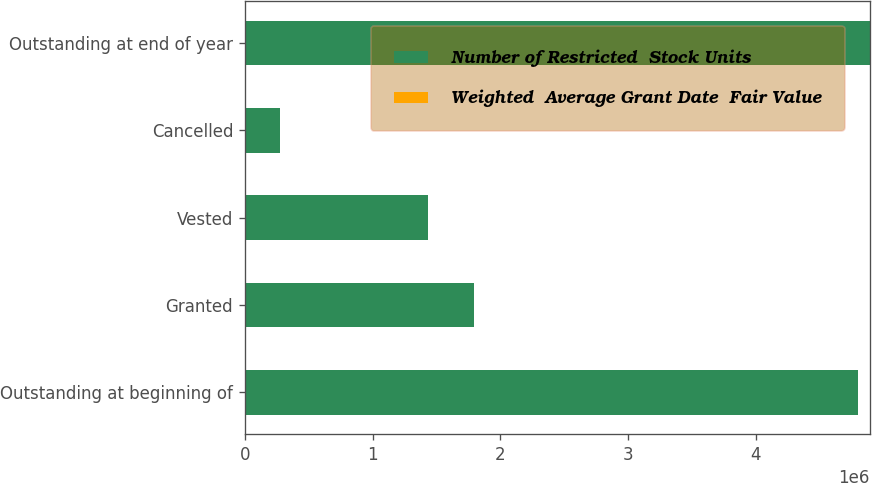<chart> <loc_0><loc_0><loc_500><loc_500><stacked_bar_chart><ecel><fcel>Outstanding at beginning of<fcel>Granted<fcel>Vested<fcel>Cancelled<fcel>Outstanding at end of year<nl><fcel>Number of Restricted  Stock Units<fcel>4.79792e+06<fcel>1.7962e+06<fcel>1.43083e+06<fcel>273762<fcel>4.88953e+06<nl><fcel>Weighted  Average Grant Date  Fair Value<fcel>31.77<fcel>33.75<fcel>29.83<fcel>32.82<fcel>33.01<nl></chart> 